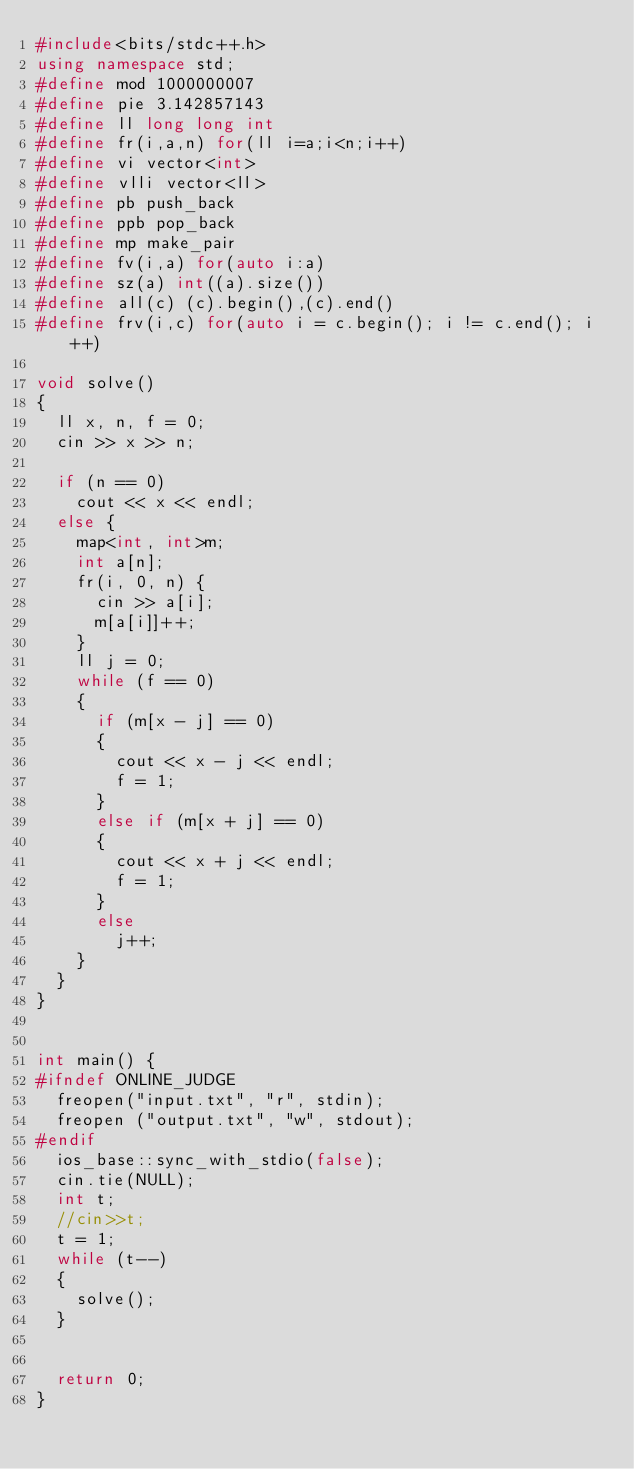Convert code to text. <code><loc_0><loc_0><loc_500><loc_500><_C++_>#include<bits/stdc++.h>
using namespace std;
#define mod 1000000007
#define pie 3.142857143
#define ll long long int
#define fr(i,a,n) for(ll i=a;i<n;i++)
#define vi vector<int>
#define vlli vector<ll>
#define pb push_back
#define ppb pop_back
#define mp make_pair
#define fv(i,a) for(auto i:a)
#define sz(a) int((a).size())
#define all(c) (c).begin(),(c).end()
#define frv(i,c) for(auto i = c.begin(); i != c.end(); i++)

void solve()
{
	ll x, n, f = 0;
	cin >> x >> n;

	if (n == 0)
		cout << x << endl;
	else {
		map<int, int>m;
		int a[n];
		fr(i, 0, n) {
			cin >> a[i];
			m[a[i]]++;
		}
		ll j = 0;
		while (f == 0)
		{
			if (m[x - j] == 0)
			{
				cout << x - j << endl;
				f = 1;
			}
			else if (m[x + j] == 0)
			{
				cout << x + j << endl;
				f = 1;
			}
			else
				j++;
		}
	}
}


int main() {
#ifndef ONLINE_JUDGE
	freopen("input.txt", "r", stdin);
	freopen ("output.txt", "w", stdout);
#endif
	ios_base::sync_with_stdio(false);
	cin.tie(NULL);
	int t;
	//cin>>t;
	t = 1;
	while (t--)
	{
		solve();
	}


	return 0;
}</code> 